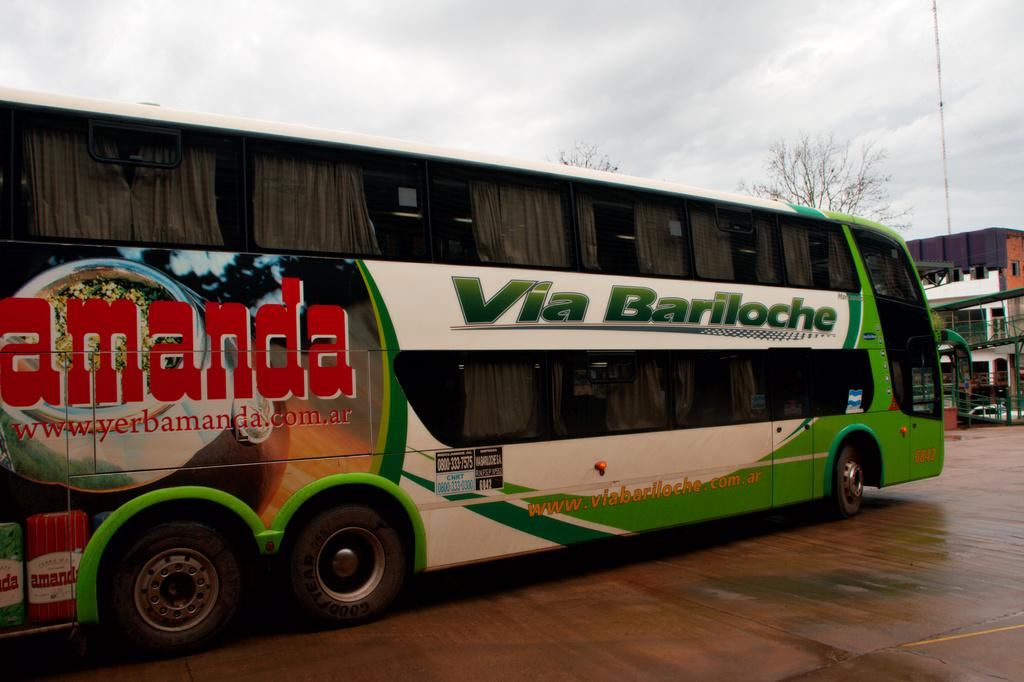What is the main subject of the image? The main subject of the image is a bus. Where is the bus located in the image? The bus is on the ground in the image. What can be seen in the background of the image? There is sky visible in the background of the image. What structures or objects are on the right side of the image? There is a building and trees on the right side of the image. What type of juice is being served in the image? There is no juice present in the image; it features a bus on the ground with a sky background and a building and trees on the right side. What role does the minister play in the image? There is no minister present in the image. 